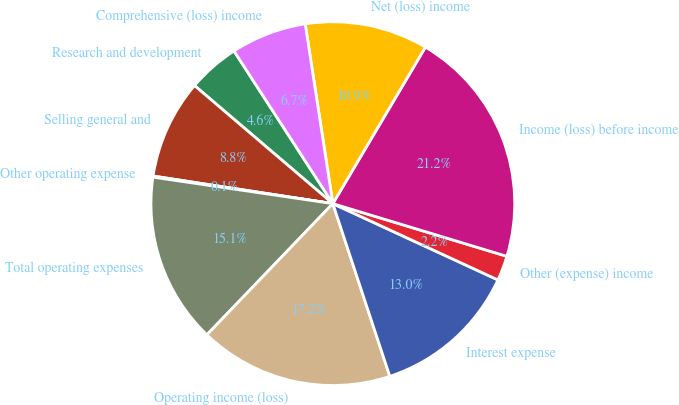Convert chart. <chart><loc_0><loc_0><loc_500><loc_500><pie_chart><fcel>Research and development<fcel>Selling general and<fcel>Other operating expense<fcel>Total operating expenses<fcel>Operating income (loss)<fcel>Interest expense<fcel>Other (expense) income<fcel>Income (loss) before income<fcel>Net (loss) income<fcel>Comprehensive (loss) income<nl><fcel>4.61%<fcel>8.82%<fcel>0.1%<fcel>15.15%<fcel>17.25%<fcel>13.04%<fcel>2.21%<fcel>21.18%<fcel>10.93%<fcel>6.72%<nl></chart> 